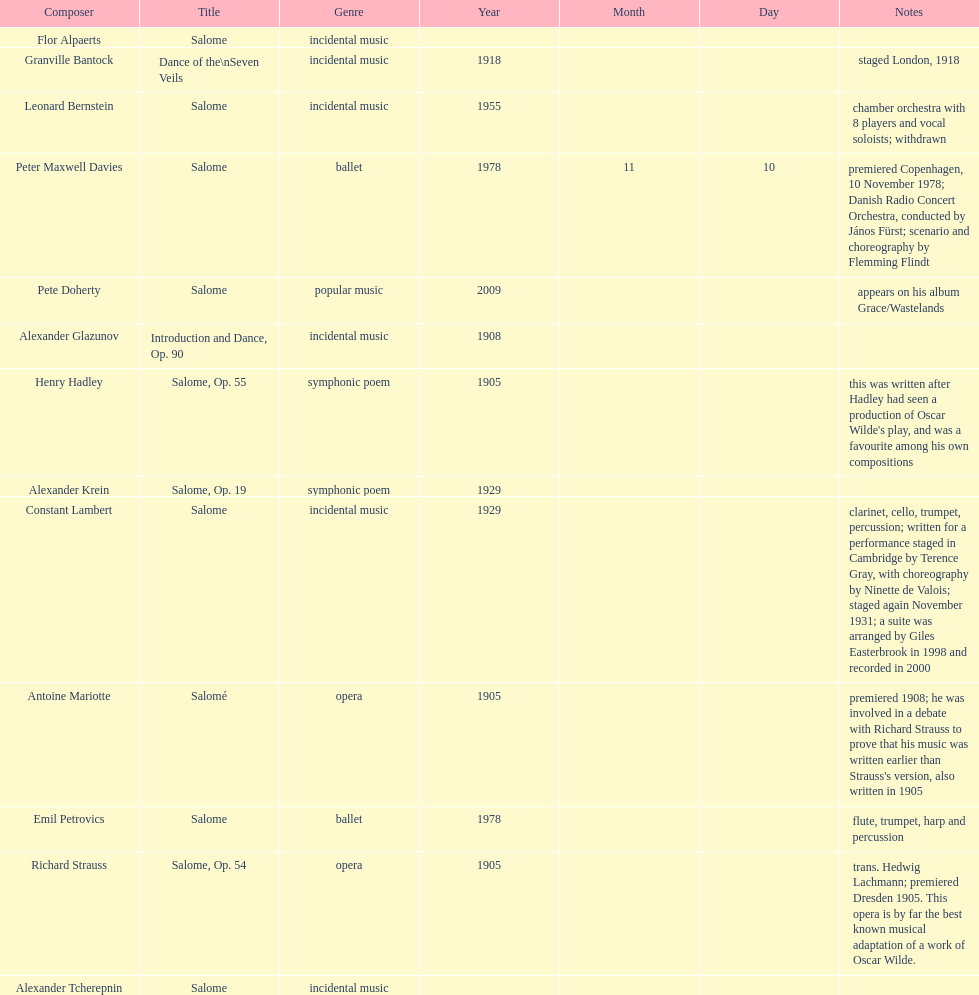What work was written after henry hadley had seen an oscar wilde play? Salome, Op. 55. 